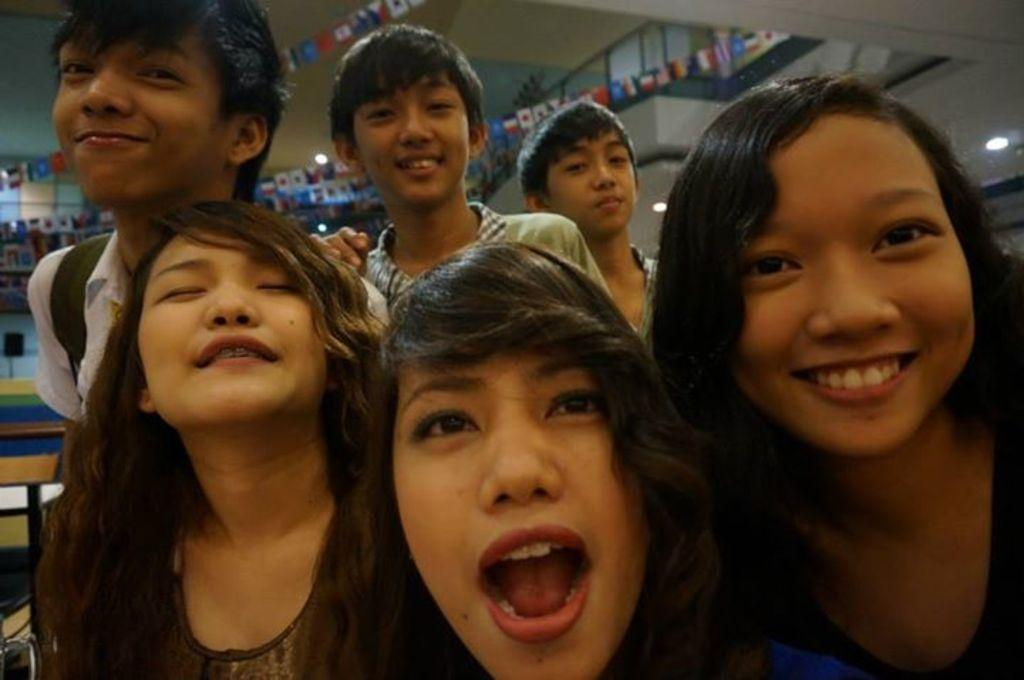What is happening in the image involving the group of people? The people in the image are smiling, which suggests they are enjoying themselves or having a good time. What can be seen in the background of the image? There is a wall, lights, and some objects visible in the background of the image. Can you describe the mood or atmosphere of the image? The smiling people and the presence of lights in the background suggest a positive and lively atmosphere. What type of volleyball game is being played in the image? There is no volleyball game present in the image; it features a group of people smiling and a background with a wall, lights, and objects. How does the snow affect the people in the image? There is no snow present in the image; it takes place indoors or in a location without snow. 